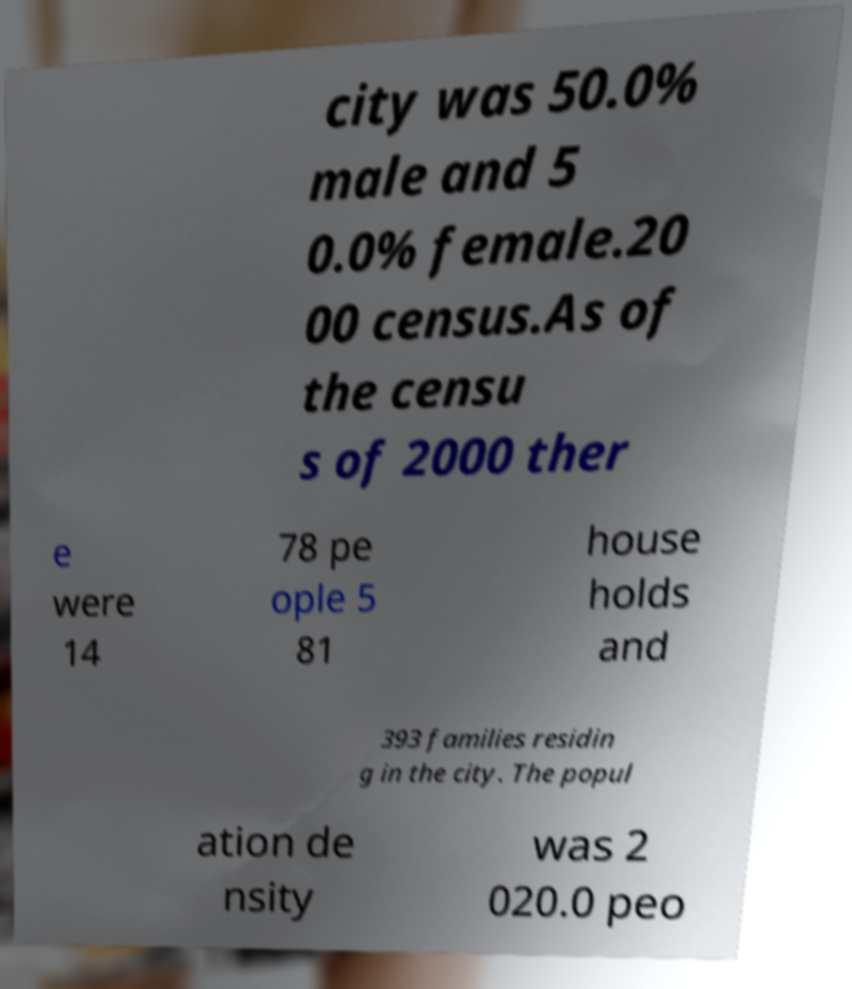I need the written content from this picture converted into text. Can you do that? city was 50.0% male and 5 0.0% female.20 00 census.As of the censu s of 2000 ther e were 14 78 pe ople 5 81 house holds and 393 families residin g in the city. The popul ation de nsity was 2 020.0 peo 